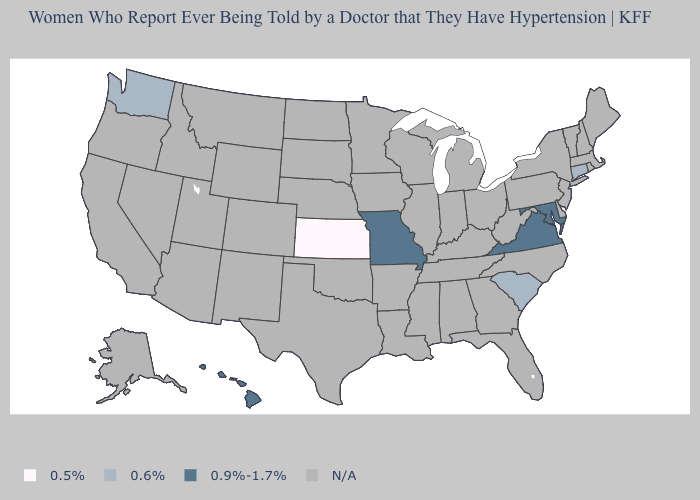Name the states that have a value in the range 0.9%-1.7%?
Give a very brief answer. Hawaii, Maryland, Missouri, Virginia. What is the value of Ohio?
Answer briefly. N/A. Is the legend a continuous bar?
Answer briefly. No. Name the states that have a value in the range 0.9%-1.7%?
Answer briefly. Hawaii, Maryland, Missouri, Virginia. Which states have the lowest value in the USA?
Be succinct. Kansas. What is the value of Washington?
Concise answer only. 0.6%. Which states have the lowest value in the USA?
Write a very short answer. Kansas. Name the states that have a value in the range 0.6%?
Be succinct. Connecticut, South Carolina, Washington. Name the states that have a value in the range 0.5%?
Keep it brief. Kansas. What is the value of South Carolina?
Short answer required. 0.6%. Is the legend a continuous bar?
Be succinct. No. 